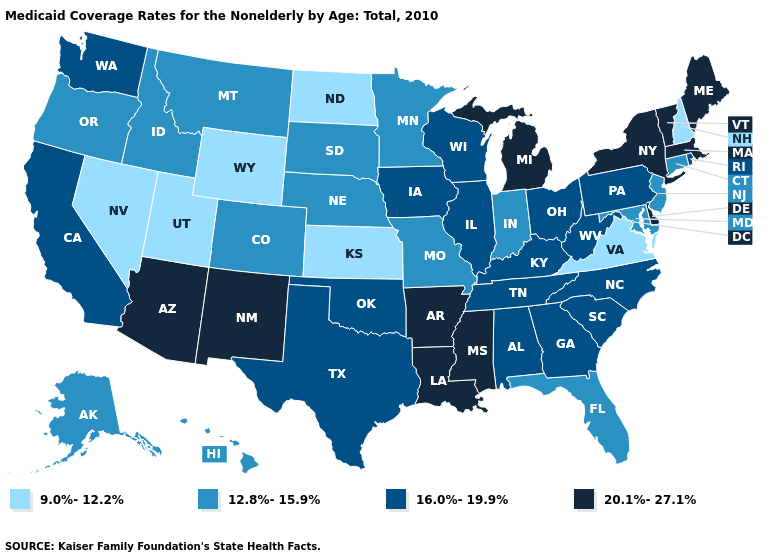Does the first symbol in the legend represent the smallest category?
Give a very brief answer. Yes. Among the states that border Texas , which have the lowest value?
Write a very short answer. Oklahoma. Among the states that border South Dakota , does Iowa have the lowest value?
Write a very short answer. No. Name the states that have a value in the range 9.0%-12.2%?
Write a very short answer. Kansas, Nevada, New Hampshire, North Dakota, Utah, Virginia, Wyoming. Is the legend a continuous bar?
Write a very short answer. No. What is the highest value in the Northeast ?
Keep it brief. 20.1%-27.1%. What is the value of Connecticut?
Concise answer only. 12.8%-15.9%. Among the states that border Arkansas , which have the lowest value?
Short answer required. Missouri. Among the states that border Nevada , which have the highest value?
Answer briefly. Arizona. What is the value of Maine?
Be succinct. 20.1%-27.1%. What is the value of Texas?
Concise answer only. 16.0%-19.9%. Among the states that border Utah , does New Mexico have the highest value?
Write a very short answer. Yes. Does Nebraska have a higher value than North Dakota?
Write a very short answer. Yes. Name the states that have a value in the range 16.0%-19.9%?
Quick response, please. Alabama, California, Georgia, Illinois, Iowa, Kentucky, North Carolina, Ohio, Oklahoma, Pennsylvania, Rhode Island, South Carolina, Tennessee, Texas, Washington, West Virginia, Wisconsin. 